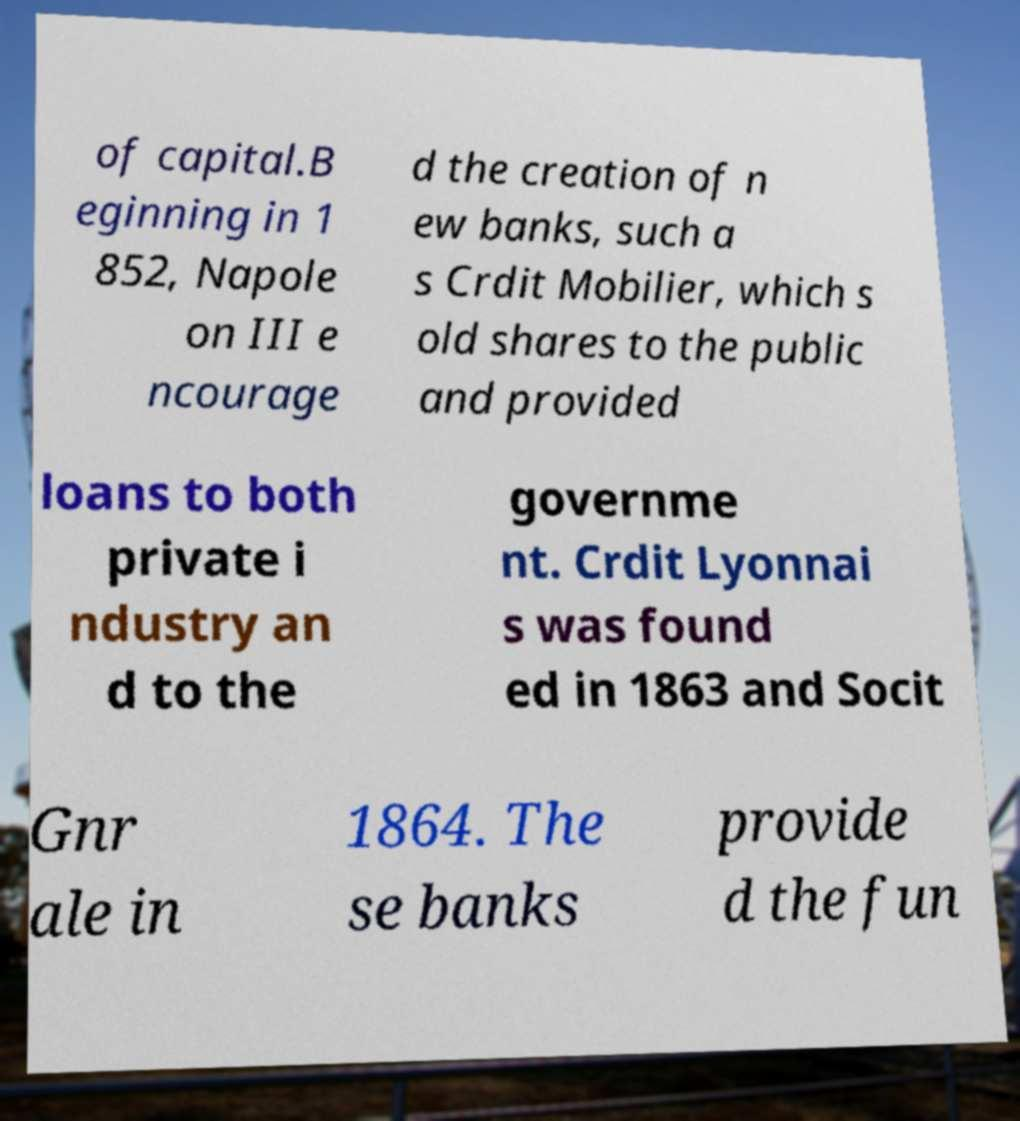Could you extract and type out the text from this image? of capital.B eginning in 1 852, Napole on III e ncourage d the creation of n ew banks, such a s Crdit Mobilier, which s old shares to the public and provided loans to both private i ndustry an d to the governme nt. Crdit Lyonnai s was found ed in 1863 and Socit Gnr ale in 1864. The se banks provide d the fun 